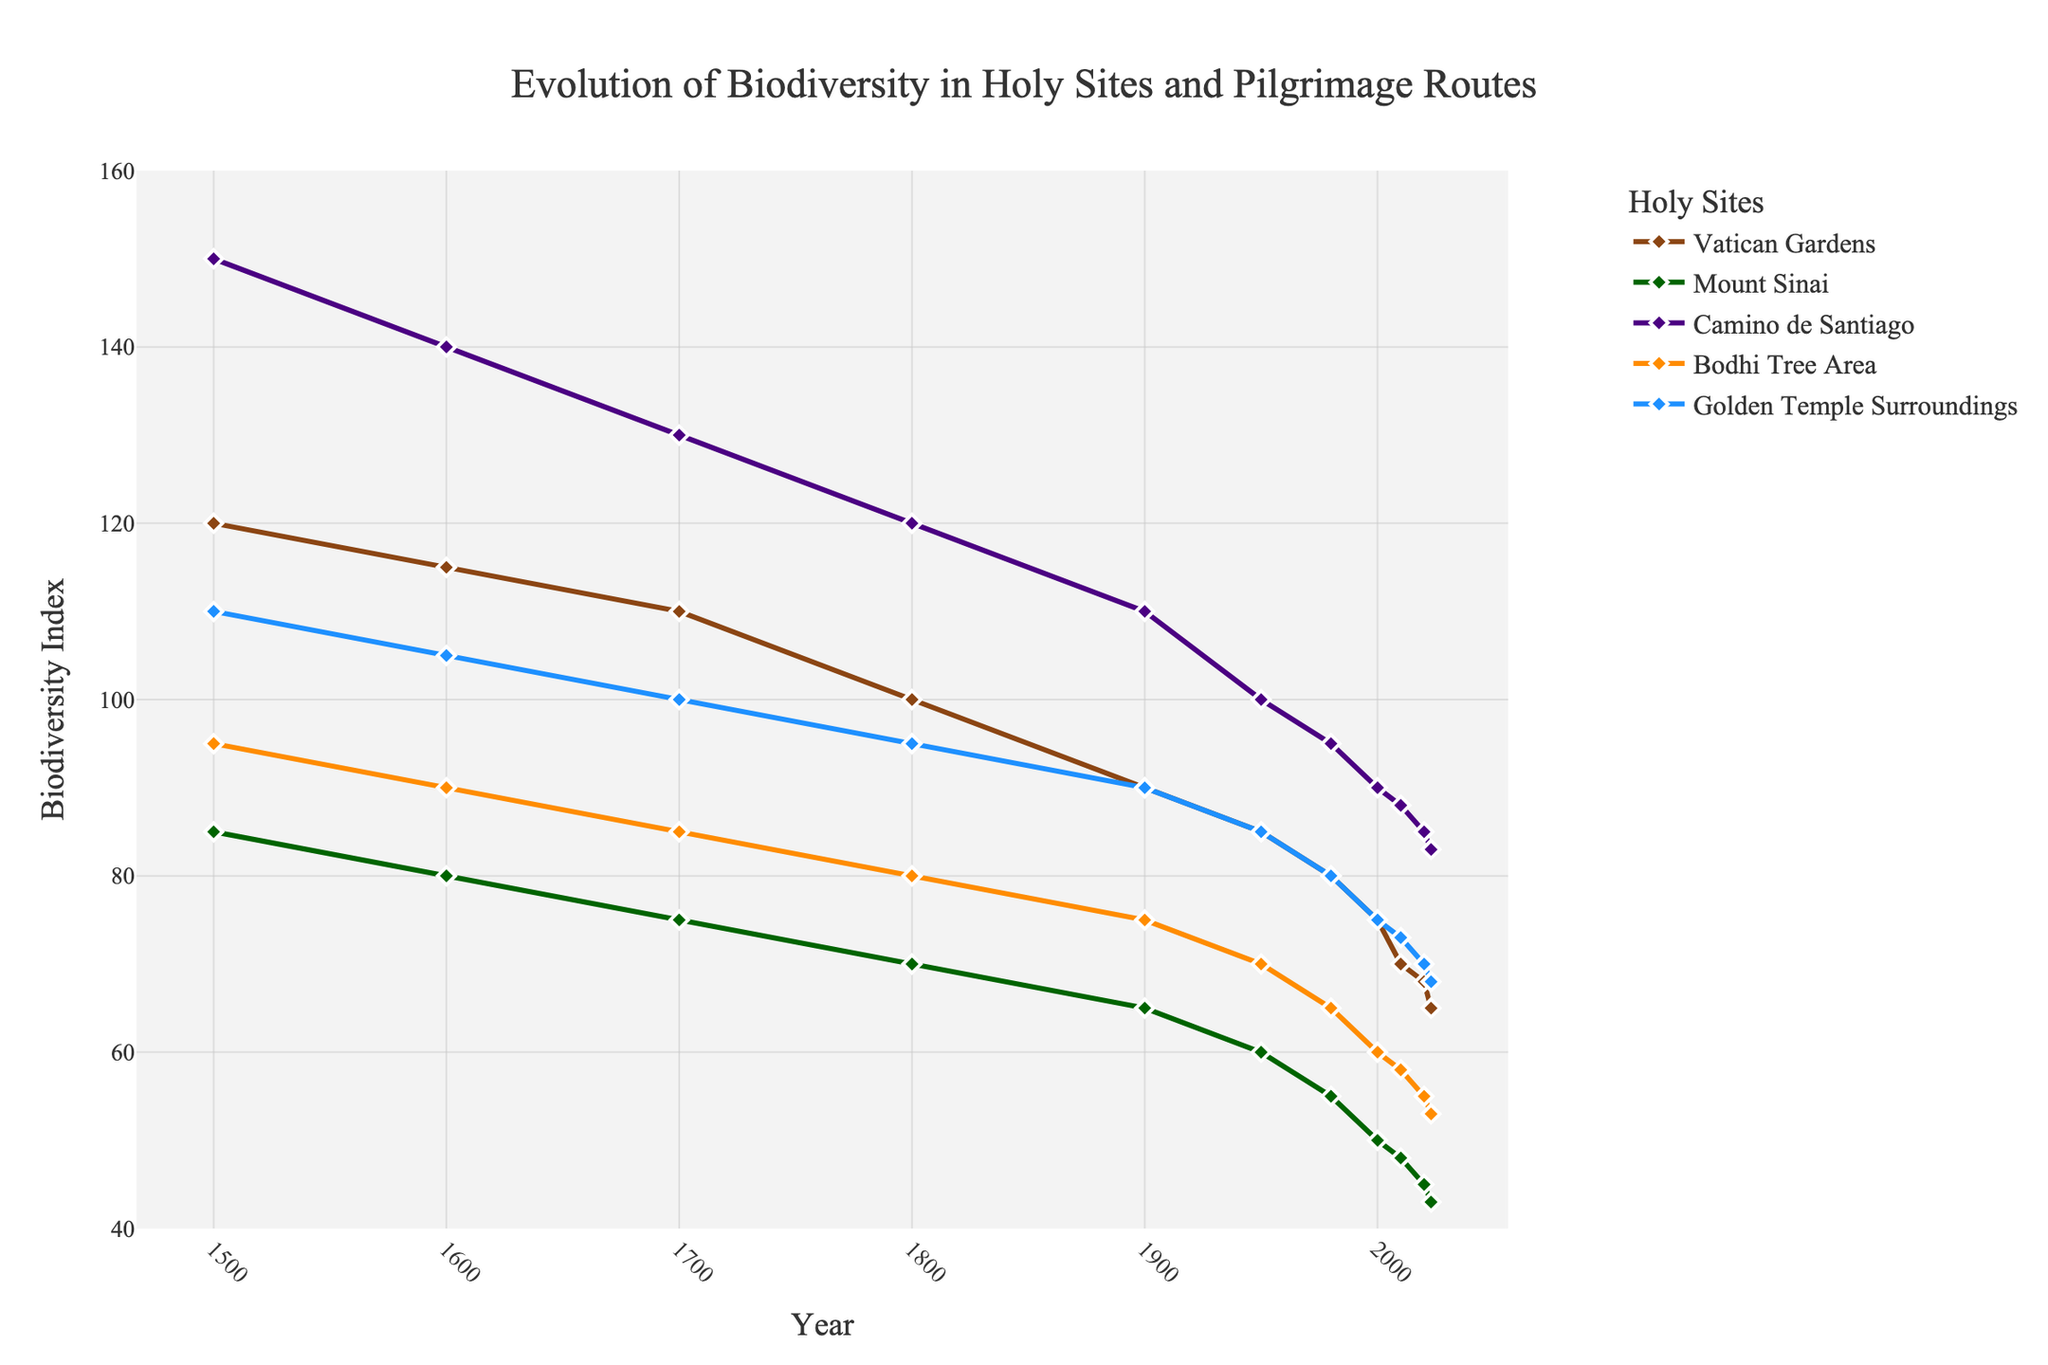What is the difference in biodiversity index between 1500 and 2023 for the Vatican Gardens? From the figure, the biodiversity index for the Vatican Gardens in 1500 is 120 and in 2023 is 65. The difference is calculated as 120 - 65 = 55.
Answer: 55 By how much has biodiversity decreased in the Mount Sinai area from 1700 to 2000? The biodiversity index for Mount Sinai in 1700 is 75 and in 2000 is 50. The decrease can be calculated as 75 - 50 = 25.
Answer: 25 Which holy site showed the smallest decrease in biodiversity index from 1500 to 2023? To find the smallest decrease, we examine the biodiversity index for each site in both years. We calculate: 
- Vatican Gardens: 120 to 65 (decrease of 55)
- Mount Sinai: 85 to 43 (decrease of 42)
- Camino de Santiago: 150 to 83 (decrease of 67)
- Bodhi Tree Area: 95 to 53 (decrease of 42)
- Golden Temple Surroundings: 110 to 68 (decrease of 42)
The smallest decrease is for Mount Sinai, Bodhi Tree Area, and Golden Temple Surroundings, all with a decrease of 42.
Answer: Mount Sinai, Bodhi Tree Area, Golden Temple Surroundings Which site had the highest biodiversity index in 1600? By observing the chart, the Camino de Santiago had the highest biodiversity index in 1600 with a value of 140.
Answer: Camino de Santiago What is the average biodiversity index for the Bodhi Tree Area in the year 2000 and 2023? The figure shows the biodiversity index for the Bodhi Tree Area as 60 in 2000 and 53 in 2023. Their average is calculated as (60 + 53) / 2 = 113 / 2 = 56.5.
Answer: 56.5 What was the biodiversity trend for the Golden Temple Surroundings from 1900 to 2023? Observing the figure, the biodiversity index for the Golden Temple Surroundings decreases continuously from 90 in 1900 to 68 in 2023, indicating a downward trend.
Answer: Downward trend Which site displayed the steepest decline in biodiversity between 1500 and 1600? From the figure, we calculate the declines for each site between 1500 and 1600:
- Vatican Gardens: 120 to 115 (decline of 5)
- Mount Sinai: 85 to 80 (decline of 5)
- Camino de Santiago: 150 to 140 (decline of 10)
- Bodhi Tree Area: 95 to 90 (decline of 5)
- Golden Temple Surroundings: 110 to 105 (decline of 5)
The steepest decline is seen in Camino de Santiago with a decline of 10.
Answer: Camino de Santiago By what percentage did the biodiversity index of the Camino de Santiago change from 1500 to 2023? Biodiversity index for Camino de Santiago in 1500 is 150 and in 2023 is 83. The percentage change is calculated as ((150 - 83) / 150) * 100 = (67 / 150) * 100 = 44.67%.
Answer: 44.67% How does biodiversity in Mount Sinai compare to that in the Vatican Gardens in 2020? In 2020, the biodiversity index for Mount Sinai is 45 and for Vatican Gardens is 68. The Vatican Gardens has a higher biodiversity index compared to Mount Sinai.
Answer: Vatican Gardens is higher What is the color of the line representing the Bodhi Tree Area? Observing the chart, the line representing the Bodhi Tree Area is colored orange.
Answer: Orange 